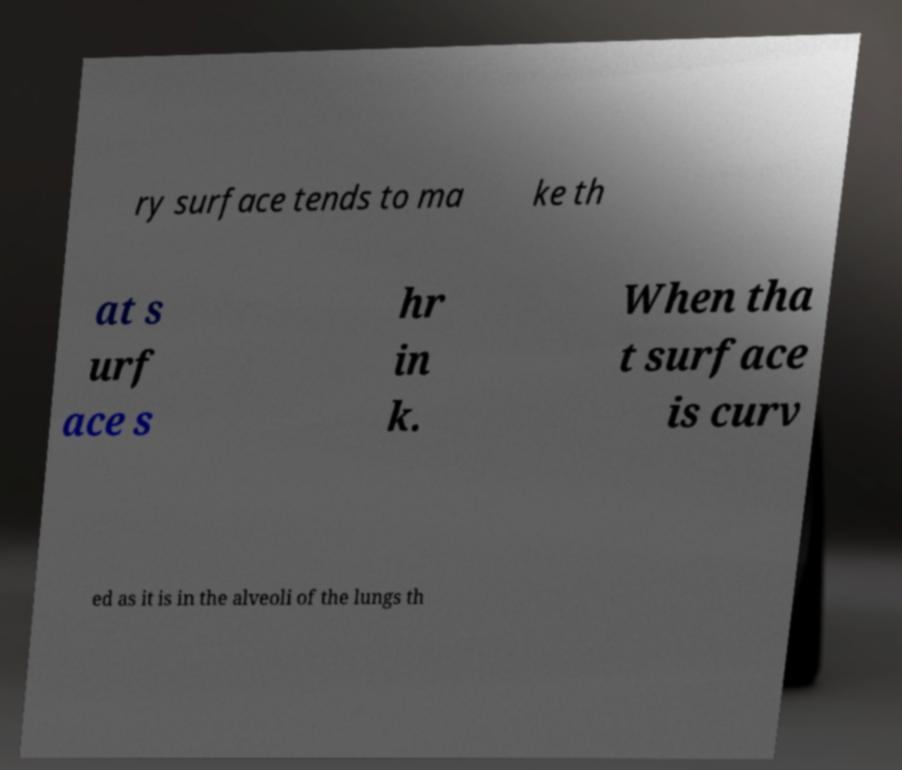Could you assist in decoding the text presented in this image and type it out clearly? ry surface tends to ma ke th at s urf ace s hr in k. When tha t surface is curv ed as it is in the alveoli of the lungs th 